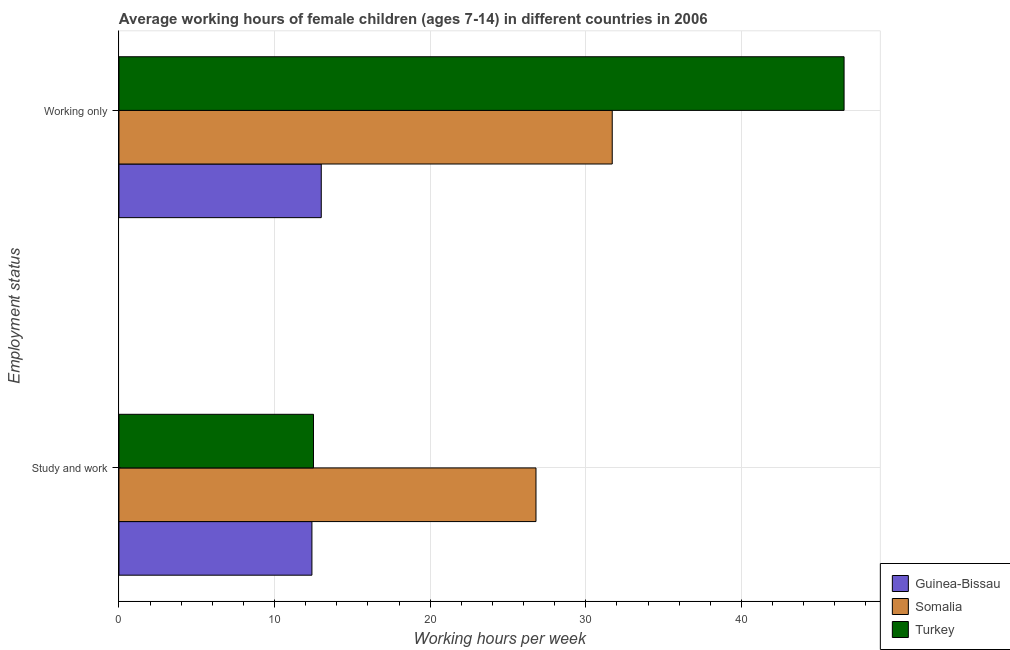How many different coloured bars are there?
Provide a succinct answer. 3. How many groups of bars are there?
Provide a succinct answer. 2. How many bars are there on the 2nd tick from the top?
Give a very brief answer. 3. What is the label of the 2nd group of bars from the top?
Your response must be concise. Study and work. Across all countries, what is the maximum average working hour of children involved in only work?
Make the answer very short. 46.6. Across all countries, what is the minimum average working hour of children involved in study and work?
Give a very brief answer. 12.4. In which country was the average working hour of children involved in only work minimum?
Ensure brevity in your answer.  Guinea-Bissau. What is the total average working hour of children involved in study and work in the graph?
Provide a short and direct response. 51.7. What is the difference between the average working hour of children involved in only work in Guinea-Bissau and that in Somalia?
Your answer should be very brief. -18.7. What is the difference between the average working hour of children involved in study and work in Somalia and the average working hour of children involved in only work in Guinea-Bissau?
Provide a succinct answer. 13.8. What is the average average working hour of children involved in study and work per country?
Give a very brief answer. 17.23. What is the difference between the average working hour of children involved in only work and average working hour of children involved in study and work in Turkey?
Make the answer very short. 34.1. What is the ratio of the average working hour of children involved in study and work in Guinea-Bissau to that in Turkey?
Ensure brevity in your answer.  0.99. In how many countries, is the average working hour of children involved in study and work greater than the average average working hour of children involved in study and work taken over all countries?
Ensure brevity in your answer.  1. What does the 1st bar from the top in Working only represents?
Provide a short and direct response. Turkey. What does the 1st bar from the bottom in Study and work represents?
Provide a succinct answer. Guinea-Bissau. How many bars are there?
Offer a terse response. 6. Are all the bars in the graph horizontal?
Keep it short and to the point. Yes. What is the difference between two consecutive major ticks on the X-axis?
Your response must be concise. 10. Are the values on the major ticks of X-axis written in scientific E-notation?
Keep it short and to the point. No. Does the graph contain grids?
Your response must be concise. Yes. Where does the legend appear in the graph?
Your answer should be compact. Bottom right. What is the title of the graph?
Ensure brevity in your answer.  Average working hours of female children (ages 7-14) in different countries in 2006. Does "West Bank and Gaza" appear as one of the legend labels in the graph?
Provide a succinct answer. No. What is the label or title of the X-axis?
Offer a terse response. Working hours per week. What is the label or title of the Y-axis?
Provide a short and direct response. Employment status. What is the Working hours per week in Guinea-Bissau in Study and work?
Provide a short and direct response. 12.4. What is the Working hours per week of Somalia in Study and work?
Offer a terse response. 26.8. What is the Working hours per week of Turkey in Study and work?
Offer a terse response. 12.5. What is the Working hours per week in Somalia in Working only?
Provide a succinct answer. 31.7. What is the Working hours per week in Turkey in Working only?
Provide a succinct answer. 46.6. Across all Employment status, what is the maximum Working hours per week in Guinea-Bissau?
Your answer should be very brief. 13. Across all Employment status, what is the maximum Working hours per week of Somalia?
Your answer should be very brief. 31.7. Across all Employment status, what is the maximum Working hours per week of Turkey?
Ensure brevity in your answer.  46.6. Across all Employment status, what is the minimum Working hours per week of Somalia?
Provide a succinct answer. 26.8. What is the total Working hours per week in Guinea-Bissau in the graph?
Make the answer very short. 25.4. What is the total Working hours per week in Somalia in the graph?
Your answer should be very brief. 58.5. What is the total Working hours per week of Turkey in the graph?
Your answer should be compact. 59.1. What is the difference between the Working hours per week in Guinea-Bissau in Study and work and that in Working only?
Your answer should be compact. -0.6. What is the difference between the Working hours per week in Somalia in Study and work and that in Working only?
Offer a terse response. -4.9. What is the difference between the Working hours per week of Turkey in Study and work and that in Working only?
Your answer should be very brief. -34.1. What is the difference between the Working hours per week of Guinea-Bissau in Study and work and the Working hours per week of Somalia in Working only?
Provide a succinct answer. -19.3. What is the difference between the Working hours per week of Guinea-Bissau in Study and work and the Working hours per week of Turkey in Working only?
Provide a succinct answer. -34.2. What is the difference between the Working hours per week in Somalia in Study and work and the Working hours per week in Turkey in Working only?
Your answer should be compact. -19.8. What is the average Working hours per week in Guinea-Bissau per Employment status?
Your response must be concise. 12.7. What is the average Working hours per week of Somalia per Employment status?
Your response must be concise. 29.25. What is the average Working hours per week of Turkey per Employment status?
Your answer should be compact. 29.55. What is the difference between the Working hours per week of Guinea-Bissau and Working hours per week of Somalia in Study and work?
Your response must be concise. -14.4. What is the difference between the Working hours per week in Guinea-Bissau and Working hours per week in Somalia in Working only?
Provide a succinct answer. -18.7. What is the difference between the Working hours per week of Guinea-Bissau and Working hours per week of Turkey in Working only?
Your answer should be compact. -33.6. What is the difference between the Working hours per week in Somalia and Working hours per week in Turkey in Working only?
Make the answer very short. -14.9. What is the ratio of the Working hours per week in Guinea-Bissau in Study and work to that in Working only?
Your answer should be very brief. 0.95. What is the ratio of the Working hours per week in Somalia in Study and work to that in Working only?
Provide a succinct answer. 0.85. What is the ratio of the Working hours per week of Turkey in Study and work to that in Working only?
Keep it short and to the point. 0.27. What is the difference between the highest and the second highest Working hours per week in Turkey?
Keep it short and to the point. 34.1. What is the difference between the highest and the lowest Working hours per week of Somalia?
Your answer should be very brief. 4.9. What is the difference between the highest and the lowest Working hours per week of Turkey?
Your answer should be compact. 34.1. 